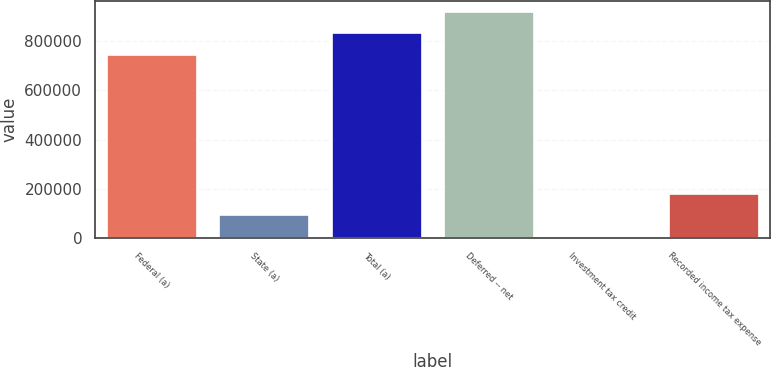<chart> <loc_0><loc_0><loc_500><loc_500><bar_chart><fcel>Federal (a)<fcel>State (a)<fcel>Total (a)<fcel>Deferred -- net<fcel>Investment tax credit<fcel>Recorded income tax expense<nl><fcel>745724<fcel>91218.5<fcel>831662<fcel>917599<fcel>5281<fcel>177156<nl></chart> 